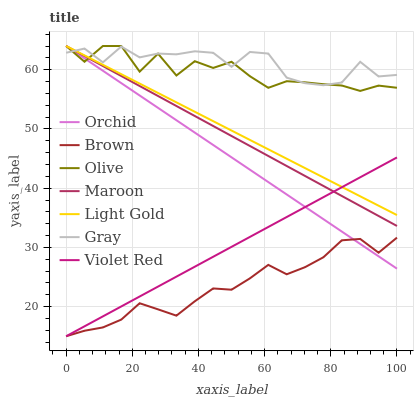Does Brown have the minimum area under the curve?
Answer yes or no. Yes. Does Gray have the maximum area under the curve?
Answer yes or no. Yes. Does Violet Red have the minimum area under the curve?
Answer yes or no. No. Does Violet Red have the maximum area under the curve?
Answer yes or no. No. Is Orchid the smoothest?
Answer yes or no. Yes. Is Olive the roughest?
Answer yes or no. Yes. Is Violet Red the smoothest?
Answer yes or no. No. Is Violet Red the roughest?
Answer yes or no. No. Does Gray have the lowest value?
Answer yes or no. No. Does Orchid have the highest value?
Answer yes or no. Yes. Does Violet Red have the highest value?
Answer yes or no. No. Is Brown less than Light Gold?
Answer yes or no. Yes. Is Light Gold greater than Brown?
Answer yes or no. Yes. Does Light Gold intersect Violet Red?
Answer yes or no. Yes. Is Light Gold less than Violet Red?
Answer yes or no. No. Is Light Gold greater than Violet Red?
Answer yes or no. No. Does Brown intersect Light Gold?
Answer yes or no. No. 